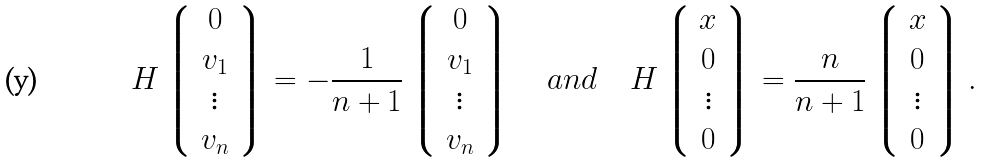Convert formula to latex. <formula><loc_0><loc_0><loc_500><loc_500>H \left \lgroup \begin{array} { c } 0 \\ v _ { 1 } \\ \vdots \\ v _ { n } \end{array} \right \rgroup = - \frac { 1 } { n + 1 } \left \lgroup \begin{array} { c } 0 \\ v _ { 1 } \\ \vdots \\ v _ { n } \end{array} \right \rgroup \quad a n d \quad H \left \lgroup \begin{array} { c } x \\ 0 \\ \vdots \\ 0 \end{array} \right \rgroup = \frac { n } { n + 1 } \left \lgroup \begin{array} { c } x \\ 0 \\ \vdots \\ 0 \end{array} \right \rgroup .</formula> 